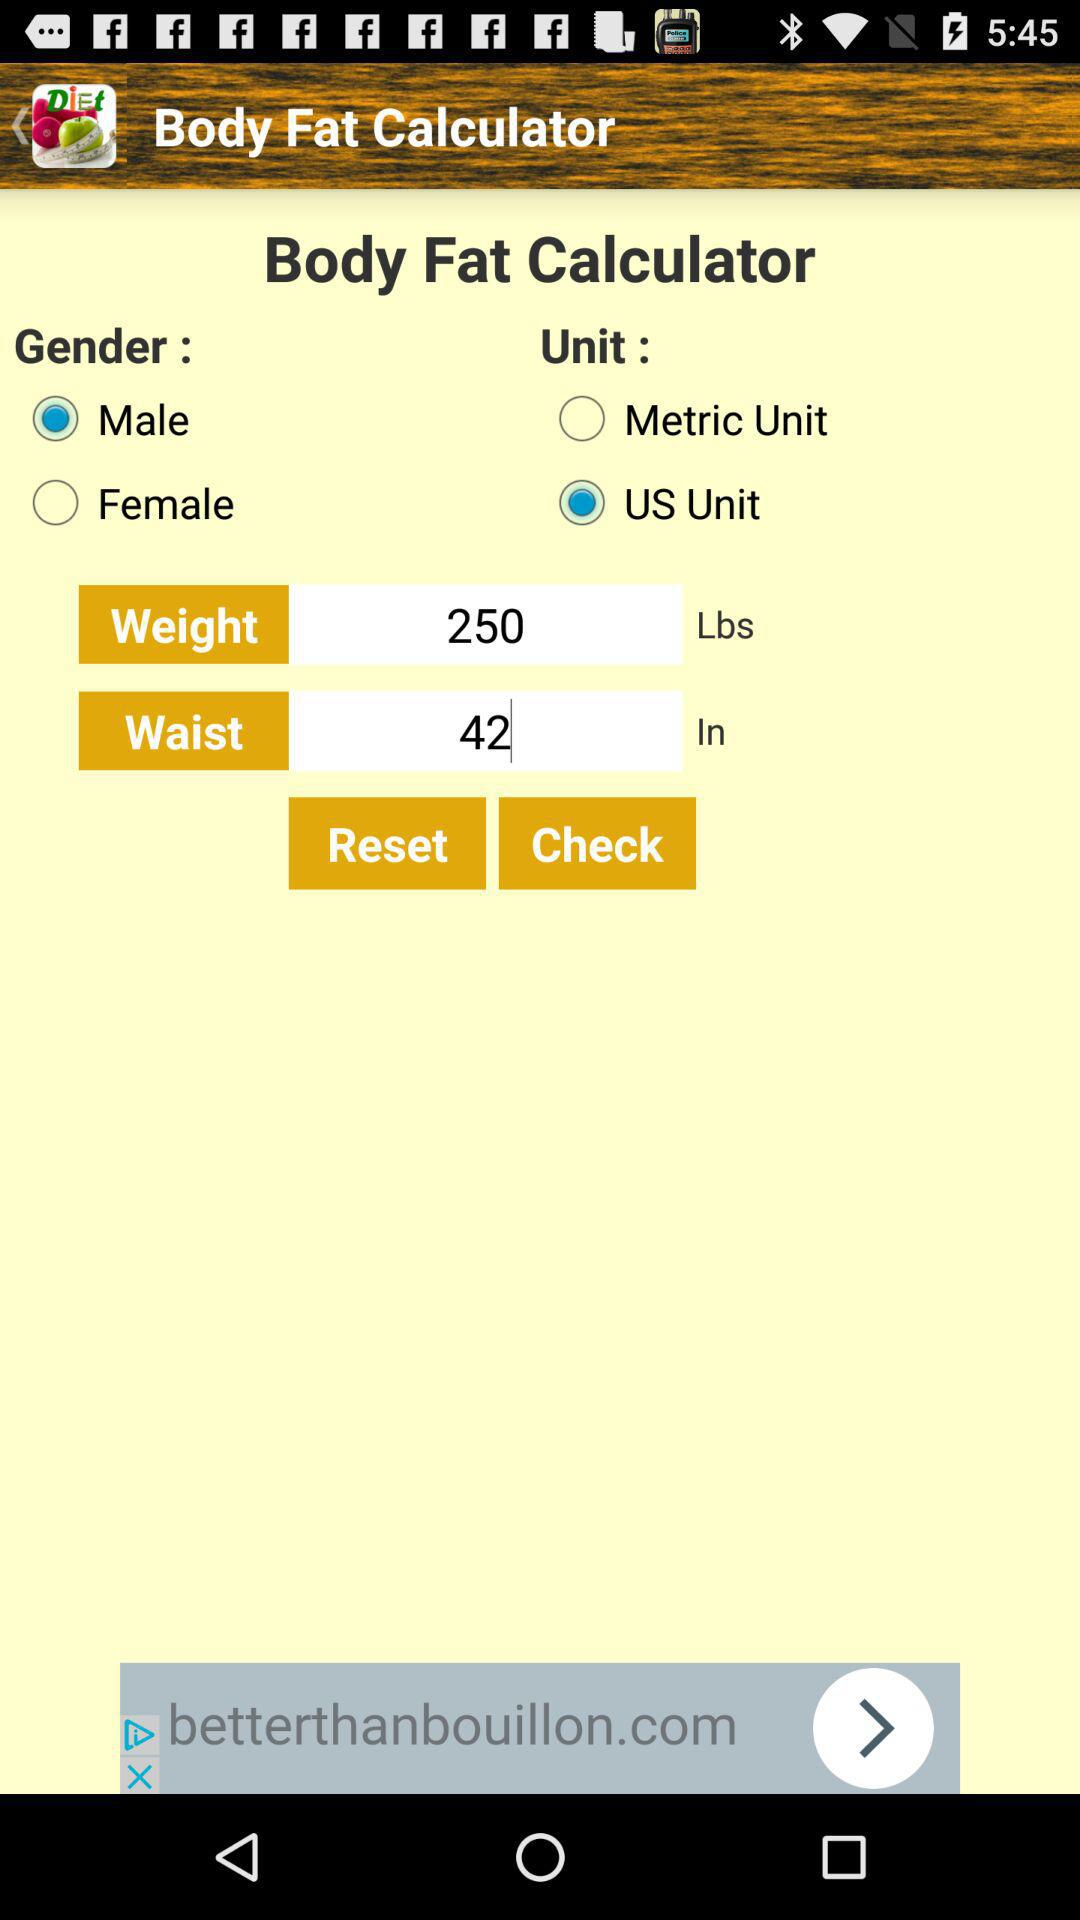What is the selected unit? The selected unit is "US Unit". 